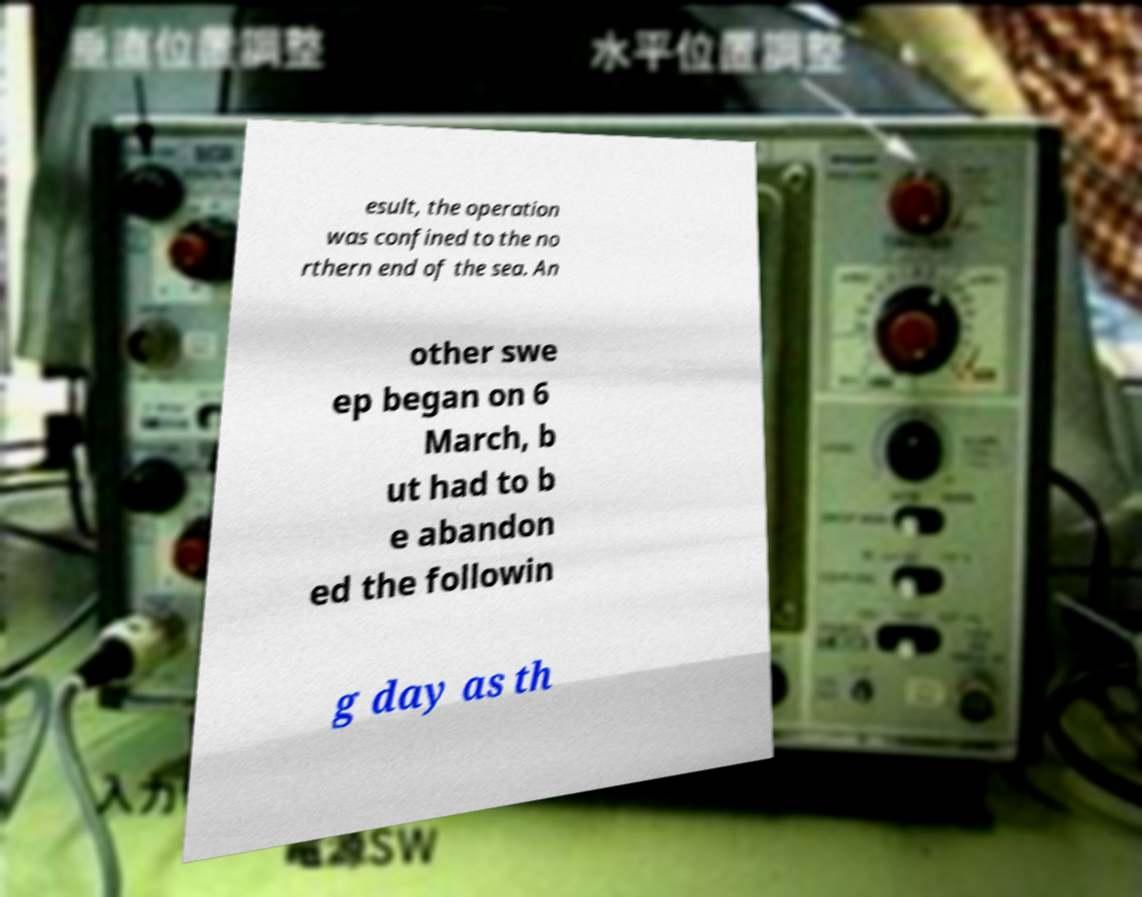There's text embedded in this image that I need extracted. Can you transcribe it verbatim? esult, the operation was confined to the no rthern end of the sea. An other swe ep began on 6 March, b ut had to b e abandon ed the followin g day as th 